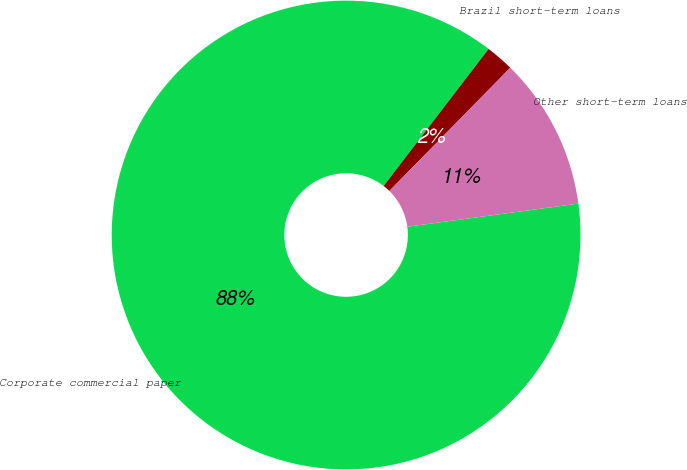Convert chart to OTSL. <chart><loc_0><loc_0><loc_500><loc_500><pie_chart><fcel>Corporate commercial paper<fcel>Brazil short-term loans<fcel>Other short-term loans<nl><fcel>87.55%<fcel>1.95%<fcel>10.51%<nl></chart> 